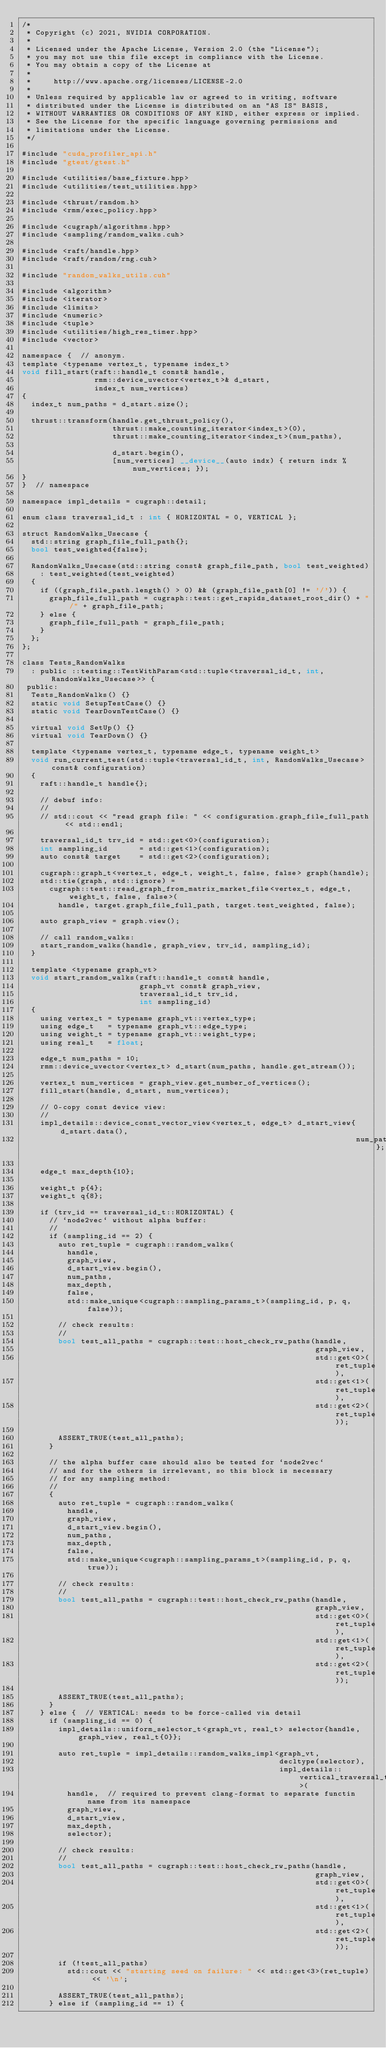<code> <loc_0><loc_0><loc_500><loc_500><_Cuda_>/*
 * Copyright (c) 2021, NVIDIA CORPORATION.
 *
 * Licensed under the Apache License, Version 2.0 (the "License");
 * you may not use this file except in compliance with the License.
 * You may obtain a copy of the License at
 *
 *     http://www.apache.org/licenses/LICENSE-2.0
 *
 * Unless required by applicable law or agreed to in writing, software
 * distributed under the License is distributed on an "AS IS" BASIS,
 * WITHOUT WARRANTIES OR CONDITIONS OF ANY KIND, either express or implied.
 * See the License for the specific language governing permissions and
 * limitations under the License.
 */

#include "cuda_profiler_api.h"
#include "gtest/gtest.h"

#include <utilities/base_fixture.hpp>
#include <utilities/test_utilities.hpp>

#include <thrust/random.h>
#include <rmm/exec_policy.hpp>

#include <cugraph/algorithms.hpp>
#include <sampling/random_walks.cuh>

#include <raft/handle.hpp>
#include <raft/random/rng.cuh>

#include "random_walks_utils.cuh"

#include <algorithm>
#include <iterator>
#include <limits>
#include <numeric>
#include <tuple>
#include <utilities/high_res_timer.hpp>
#include <vector>

namespace {  // anonym.
template <typename vertex_t, typename index_t>
void fill_start(raft::handle_t const& handle,
                rmm::device_uvector<vertex_t>& d_start,
                index_t num_vertices)
{
  index_t num_paths = d_start.size();

  thrust::transform(handle.get_thrust_policy(),
                    thrust::make_counting_iterator<index_t>(0),
                    thrust::make_counting_iterator<index_t>(num_paths),

                    d_start.begin(),
                    [num_vertices] __device__(auto indx) { return indx % num_vertices; });
}
}  // namespace

namespace impl_details = cugraph::detail;

enum class traversal_id_t : int { HORIZONTAL = 0, VERTICAL };

struct RandomWalks_Usecase {
  std::string graph_file_full_path{};
  bool test_weighted{false};

  RandomWalks_Usecase(std::string const& graph_file_path, bool test_weighted)
    : test_weighted(test_weighted)
  {
    if ((graph_file_path.length() > 0) && (graph_file_path[0] != '/')) {
      graph_file_full_path = cugraph::test::get_rapids_dataset_root_dir() + "/" + graph_file_path;
    } else {
      graph_file_full_path = graph_file_path;
    }
  };
};

class Tests_RandomWalks
  : public ::testing::TestWithParam<std::tuple<traversal_id_t, int, RandomWalks_Usecase>> {
 public:
  Tests_RandomWalks() {}
  static void SetupTestCase() {}
  static void TearDownTestCase() {}

  virtual void SetUp() {}
  virtual void TearDown() {}

  template <typename vertex_t, typename edge_t, typename weight_t>
  void run_current_test(std::tuple<traversal_id_t, int, RandomWalks_Usecase> const& configuration)
  {
    raft::handle_t handle{};

    // debuf info:
    //
    // std::cout << "read graph file: " << configuration.graph_file_full_path << std::endl;

    traversal_id_t trv_id = std::get<0>(configuration);
    int sampling_id       = std::get<1>(configuration);
    auto const& target    = std::get<2>(configuration);

    cugraph::graph_t<vertex_t, edge_t, weight_t, false, false> graph(handle);
    std::tie(graph, std::ignore) =
      cugraph::test::read_graph_from_matrix_market_file<vertex_t, edge_t, weight_t, false, false>(
        handle, target.graph_file_full_path, target.test_weighted, false);

    auto graph_view = graph.view();

    // call random_walks:
    start_random_walks(handle, graph_view, trv_id, sampling_id);
  }

  template <typename graph_vt>
  void start_random_walks(raft::handle_t const& handle,
                          graph_vt const& graph_view,
                          traversal_id_t trv_id,
                          int sampling_id)
  {
    using vertex_t = typename graph_vt::vertex_type;
    using edge_t   = typename graph_vt::edge_type;
    using weight_t = typename graph_vt::weight_type;
    using real_t   = float;

    edge_t num_paths = 10;
    rmm::device_uvector<vertex_t> d_start(num_paths, handle.get_stream());

    vertex_t num_vertices = graph_view.get_number_of_vertices();
    fill_start(handle, d_start, num_vertices);

    // 0-copy const device view:
    //
    impl_details::device_const_vector_view<vertex_t, edge_t> d_start_view{d_start.data(),
                                                                          num_paths};

    edge_t max_depth{10};

    weight_t p{4};
    weight_t q{8};

    if (trv_id == traversal_id_t::HORIZONTAL) {
      // `node2vec` without alpha buffer:
      //
      if (sampling_id == 2) {
        auto ret_tuple = cugraph::random_walks(
          handle,
          graph_view,
          d_start_view.begin(),
          num_paths,
          max_depth,
          false,
          std::make_unique<cugraph::sampling_params_t>(sampling_id, p, q, false));

        // check results:
        //
        bool test_all_paths = cugraph::test::host_check_rw_paths(handle,
                                                                 graph_view,
                                                                 std::get<0>(ret_tuple),
                                                                 std::get<1>(ret_tuple),
                                                                 std::get<2>(ret_tuple));

        ASSERT_TRUE(test_all_paths);
      }

      // the alpha buffer case should also be tested for `node2vec`
      // and for the others is irrelevant, so this block is necessary
      // for any sampling method:
      //
      {
        auto ret_tuple = cugraph::random_walks(
          handle,
          graph_view,
          d_start_view.begin(),
          num_paths,
          max_depth,
          false,
          std::make_unique<cugraph::sampling_params_t>(sampling_id, p, q, true));

        // check results:
        //
        bool test_all_paths = cugraph::test::host_check_rw_paths(handle,
                                                                 graph_view,
                                                                 std::get<0>(ret_tuple),
                                                                 std::get<1>(ret_tuple),
                                                                 std::get<2>(ret_tuple));

        ASSERT_TRUE(test_all_paths);
      }
    } else {  // VERTICAL: needs to be force-called via detail
      if (sampling_id == 0) {
        impl_details::uniform_selector_t<graph_vt, real_t> selector{handle, graph_view, real_t{0}};

        auto ret_tuple = impl_details::random_walks_impl<graph_vt,
                                                         decltype(selector),
                                                         impl_details::vertical_traversal_t>(
          handle,  // required to prevent clang-format to separate functin name from its namespace
          graph_view,
          d_start_view,
          max_depth,
          selector);

        // check results:
        //
        bool test_all_paths = cugraph::test::host_check_rw_paths(handle,
                                                                 graph_view,
                                                                 std::get<0>(ret_tuple),
                                                                 std::get<1>(ret_tuple),
                                                                 std::get<2>(ret_tuple));

        if (!test_all_paths)
          std::cout << "starting seed on failure: " << std::get<3>(ret_tuple) << '\n';

        ASSERT_TRUE(test_all_paths);
      } else if (sampling_id == 1) {</code> 